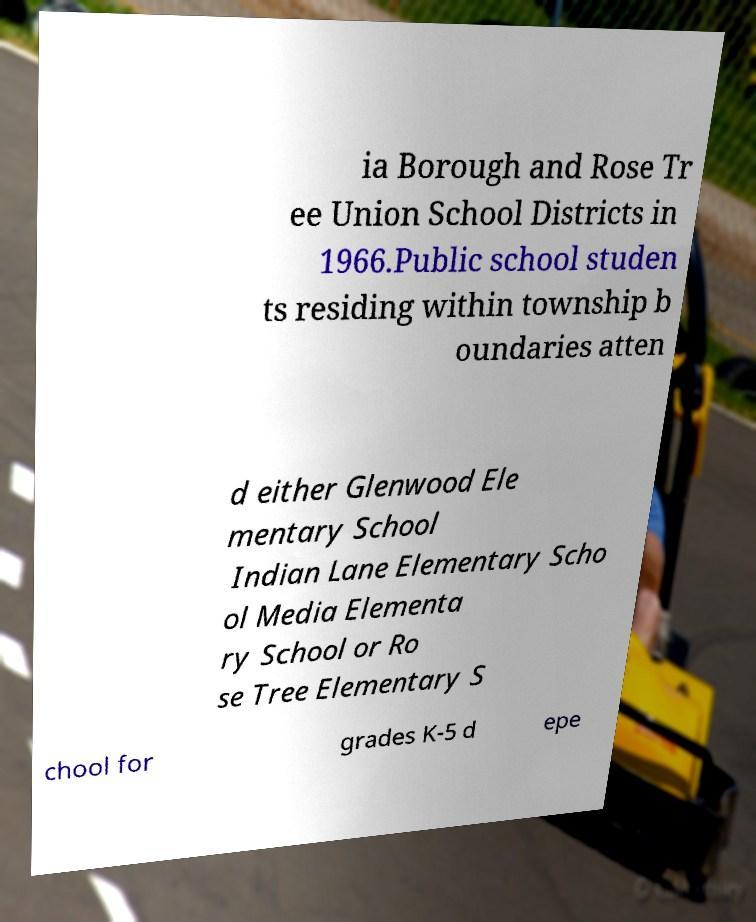Please identify and transcribe the text found in this image. ia Borough and Rose Tr ee Union School Districts in 1966.Public school studen ts residing within township b oundaries atten d either Glenwood Ele mentary School Indian Lane Elementary Scho ol Media Elementa ry School or Ro se Tree Elementary S chool for grades K-5 d epe 